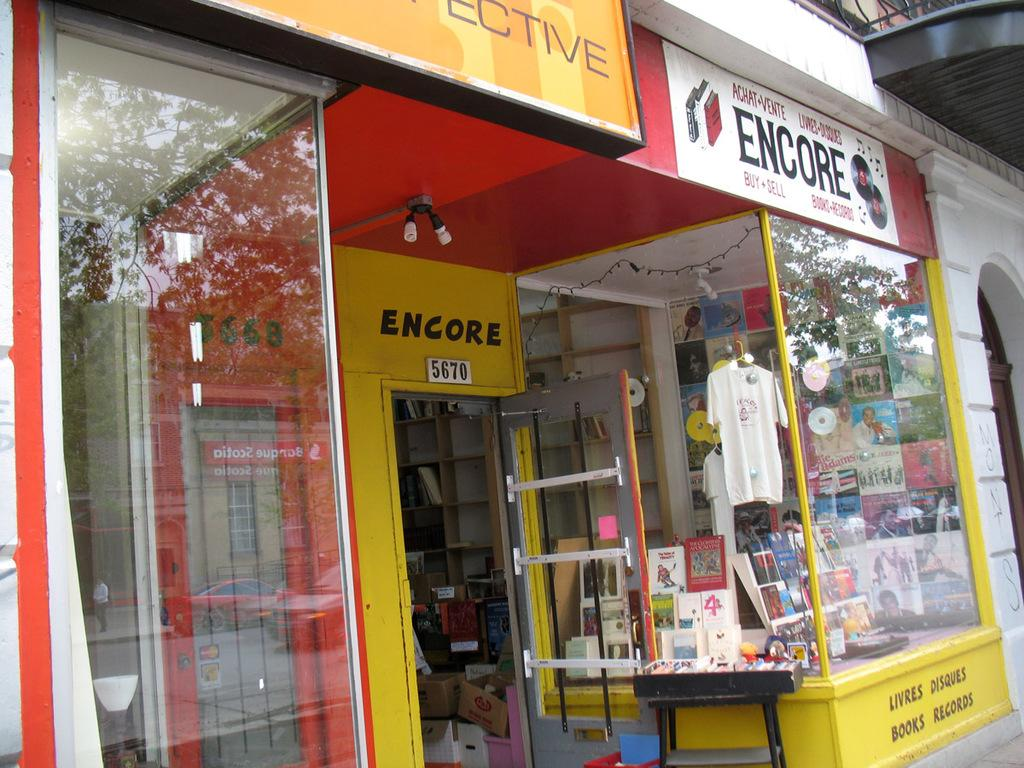<image>
Render a clear and concise summary of the photo. Yellow and red storefront for Encore with the address 5670. 